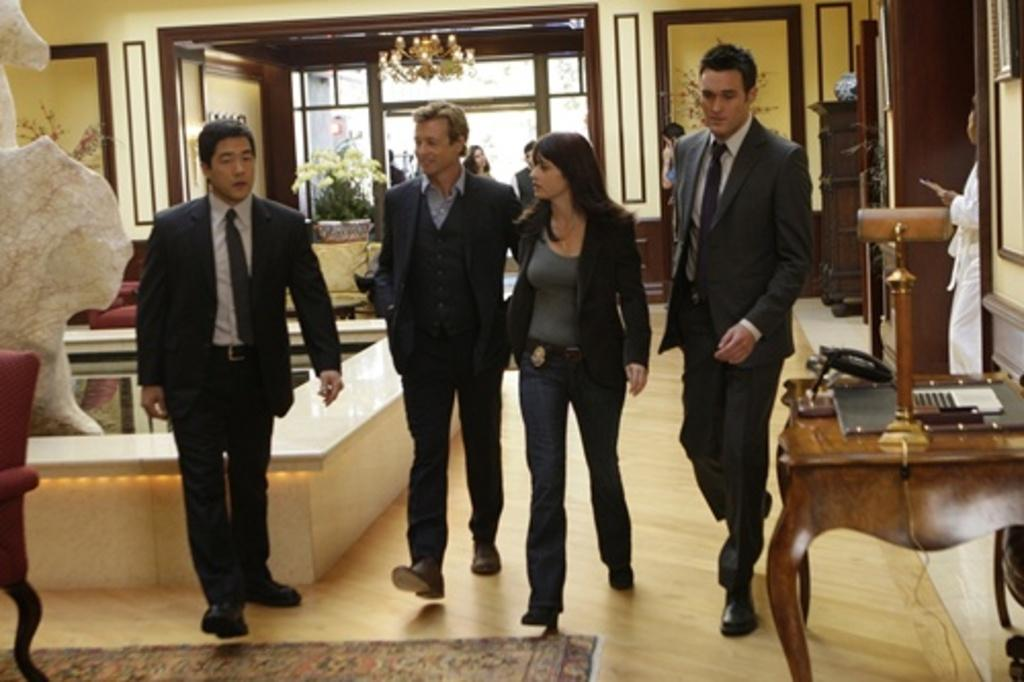How many people are walking in the image? There are four persons walking in the image. What surface are the persons walking on? The persons are walking on the floor. What furniture can be seen in the image? There is a table in the image. Is there any greenery present in the image? Yes, there is a plant on or near the table. What architectural feature is visible in the background of the image? There is a door visible in the background of the image. What type of decoration is present on the wall in the image? There are frames on the wall in the image. What type of ticket is visible on the wall in the image? There is no ticket visible on the wall in the image; only frames are present. Is there any wire visible in the image? There is no wire visible in the image. 